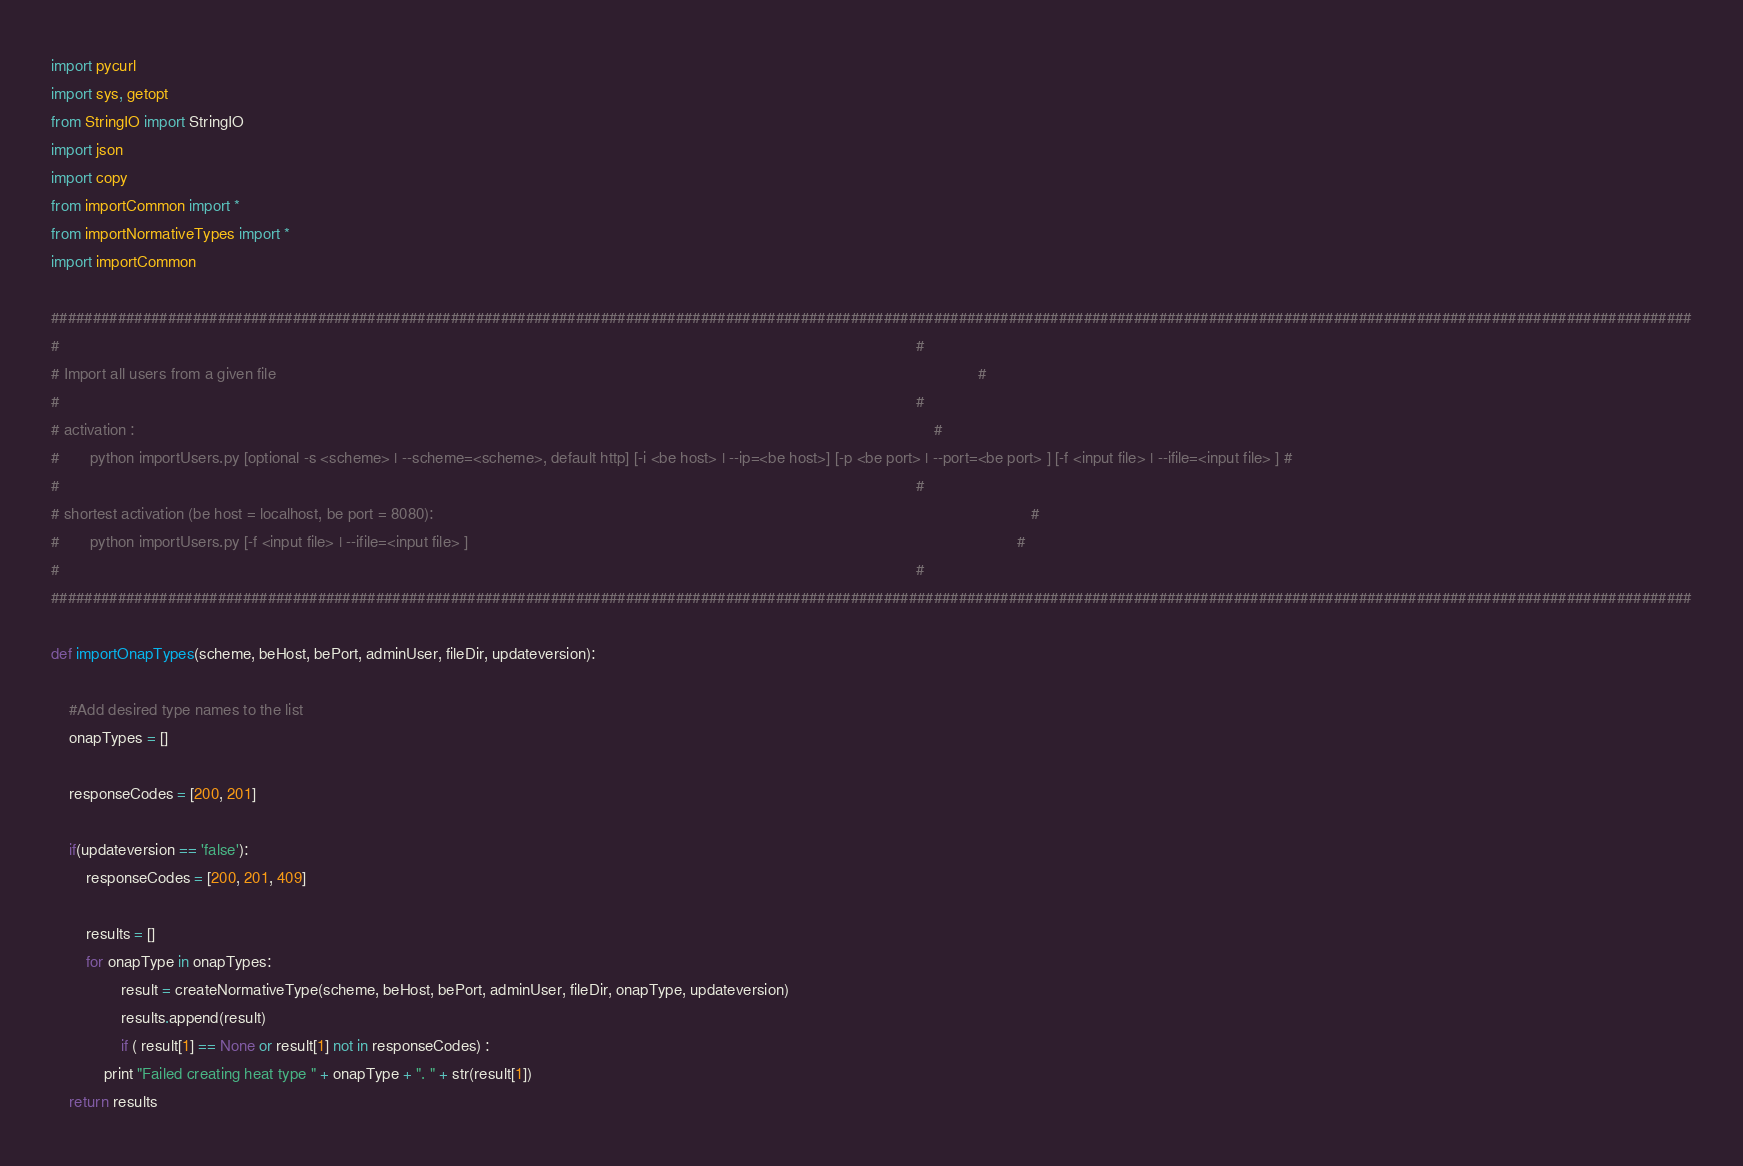Convert code to text. <code><loc_0><loc_0><loc_500><loc_500><_Python_>import pycurl
import sys, getopt
from StringIO import StringIO
import json
import copy
from importCommon import *
from importNormativeTypes import *
import importCommon

#####################################################################################################################################################################################################
#																																		       														#	
# Import all users from a given file																										   														#
# 																																			   														#		
# activation :																																   														#
#       python importUsers.py [optional -s <scheme> | --scheme=<scheme>, default http] [-i <be host> | --ip=<be host>] [-p <be port> | --port=<be port> ] [-f <input file> | --ifile=<input file> ] #
#																																		  	  														#			
# shortest activation (be host = localhost, be port = 8080): 																				   														#
#		python importUsers.py [-f <input file> | --ifile=<input file> ]												 				           														#
#																																		       														#	
#####################################################################################################################################################################################################

def importOnapTypes(scheme, beHost, bePort, adminUser, fileDir, updateversion):

	#Add desired type names to the list
	onapTypes = []
		
	responseCodes = [200, 201]
		
	if(updateversion == 'false'):
		responseCodes = [200, 201, 409]
		
        results = []
        for onapType in onapTypes:
                result = createNormativeType(scheme, beHost, bePort, adminUser, fileDir, onapType, updateversion)
                results.append(result)
                if ( result[1] == None or result[1] not in responseCodes) :
			print "Failed creating heat type " + onapType + ". " + str(result[1]) 				
	return results	

</code> 